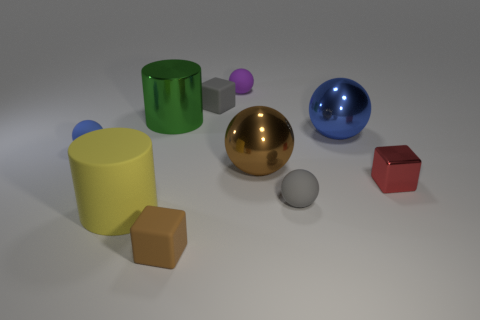What material is the thing that is in front of the cylinder that is on the left side of the big metal thing left of the brown matte cube?
Your response must be concise. Rubber. What number of other objects are there of the same size as the red cube?
Your answer should be compact. 5. Is the color of the tiny metal thing the same as the large metal cylinder?
Offer a terse response. No. What number of metallic cylinders are to the right of the small rubber cube left of the tiny matte block that is behind the brown block?
Your answer should be compact. 0. What material is the green cylinder that is left of the gray thing in front of the red metal object?
Your response must be concise. Metal. Are there any green objects of the same shape as the small red shiny object?
Give a very brief answer. No. What color is the metal cylinder that is the same size as the rubber cylinder?
Offer a terse response. Green. How many objects are cubes that are in front of the gray ball or big things that are left of the purple rubber thing?
Ensure brevity in your answer.  3. How many things are tiny purple balls or big shiny things?
Your answer should be very brief. 4. How big is the thing that is to the left of the brown block and on the right side of the yellow matte thing?
Offer a terse response. Large. 